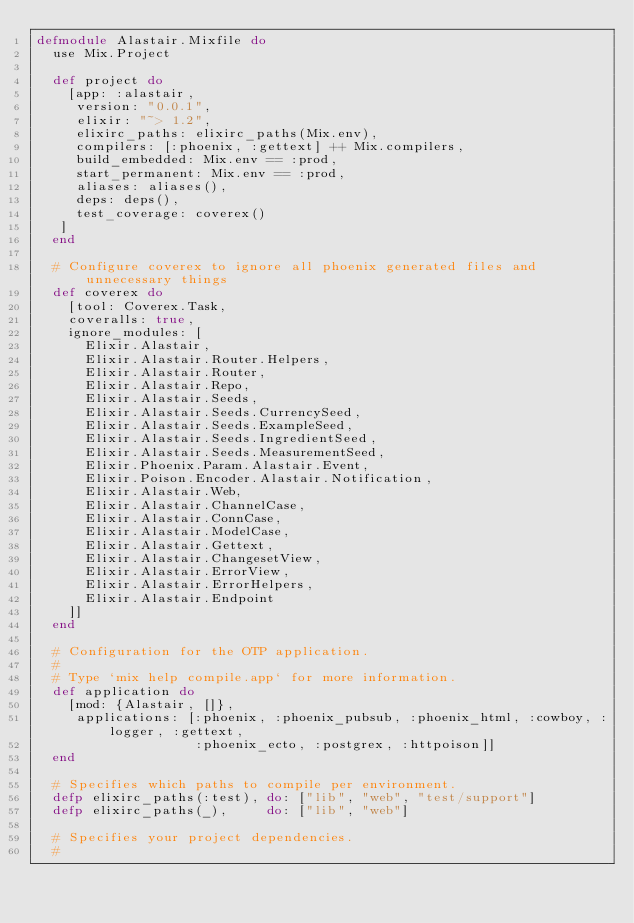Convert code to text. <code><loc_0><loc_0><loc_500><loc_500><_Elixir_>defmodule Alastair.Mixfile do
  use Mix.Project

  def project do
    [app: :alastair,
     version: "0.0.1",
     elixir: "~> 1.2",
     elixirc_paths: elixirc_paths(Mix.env),
     compilers: [:phoenix, :gettext] ++ Mix.compilers,
     build_embedded: Mix.env == :prod,
     start_permanent: Mix.env == :prod,
     aliases: aliases(),
     deps: deps(),
     test_coverage: coverex()
   ]
  end

  # Configure coverex to ignore all phoenix generated files and unnecessary things
  def coverex do
    [tool: Coverex.Task,
    coveralls: true,
    ignore_modules: [
      Elixir.Alastair,
      Elixir.Alastair.Router.Helpers,
      Elixir.Alastair.Router, 
      Elixir.Alastair.Repo, 
      Elixir.Alastair.Seeds,
      Elixir.Alastair.Seeds.CurrencySeed,
      Elixir.Alastair.Seeds.ExampleSeed,
      Elixir.Alastair.Seeds.IngredientSeed,
      Elixir.Alastair.Seeds.MeasurementSeed,
      Elixir.Phoenix.Param.Alastair.Event,
      Elixir.Poison.Encoder.Alastair.Notification,
      Elixir.Alastair.Web,
      Elixir.Alastair.ChannelCase,
      Elixir.Alastair.ConnCase,
      Elixir.Alastair.ModelCase,
      Elixir.Alastair.Gettext,
      Elixir.Alastair.ChangesetView,
      Elixir.Alastair.ErrorView,
      Elixir.Alastair.ErrorHelpers,
      Elixir.Alastair.Endpoint
    ]]
  end

  # Configuration for the OTP application.
  #
  # Type `mix help compile.app` for more information.
  def application do
    [mod: {Alastair, []},
     applications: [:phoenix, :phoenix_pubsub, :phoenix_html, :cowboy, :logger, :gettext,
                    :phoenix_ecto, :postgrex, :httpoison]]
  end

  # Specifies which paths to compile per environment.
  defp elixirc_paths(:test), do: ["lib", "web", "test/support"]
  defp elixirc_paths(_),     do: ["lib", "web"]

  # Specifies your project dependencies.
  #</code> 